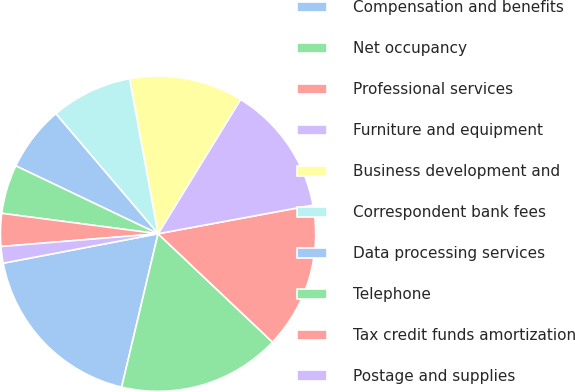Convert chart. <chart><loc_0><loc_0><loc_500><loc_500><pie_chart><fcel>Compensation and benefits<fcel>Net occupancy<fcel>Professional services<fcel>Furniture and equipment<fcel>Business development and<fcel>Correspondent bank fees<fcel>Data processing services<fcel>Telephone<fcel>Tax credit funds amortization<fcel>Postage and supplies<nl><fcel>18.3%<fcel>16.64%<fcel>14.98%<fcel>13.32%<fcel>11.66%<fcel>8.34%<fcel>6.68%<fcel>5.02%<fcel>3.36%<fcel>1.7%<nl></chart> 